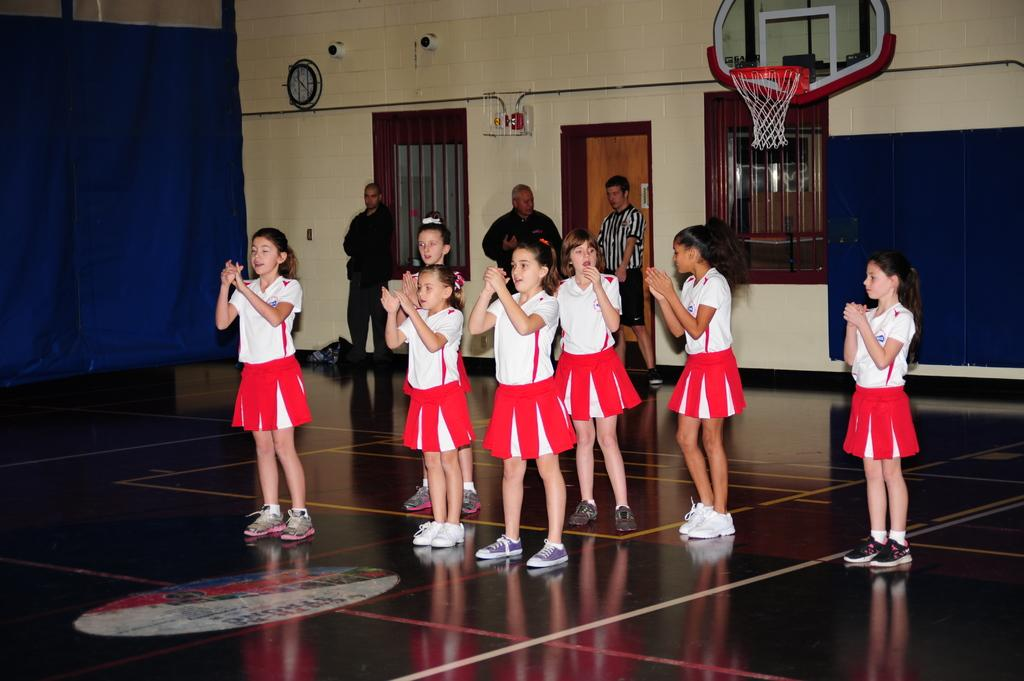How many girls are standing in the image? There is a group of girls standing in the image, but the exact number is not specified. What surface are the girls standing on? The girls are standing on the floor. How many men are visible in the image? There are three men visible in the image. What sports-related object is present in the image? A basketball hoop is present in the image. What time-keeping device is visible in the image? A clock is visible in the image. What architectural features can be seen in the image? There is a wall and a door in the image. What type of material is present in the image? Cloth is present in the image. What type of openings are visible in the image? Windows are visible in the image. What type of history can be seen in the image? There is no specific historical event or reference visible in the image. Can you see a jellyfish in the image? There is no jellyfish present in the image. 